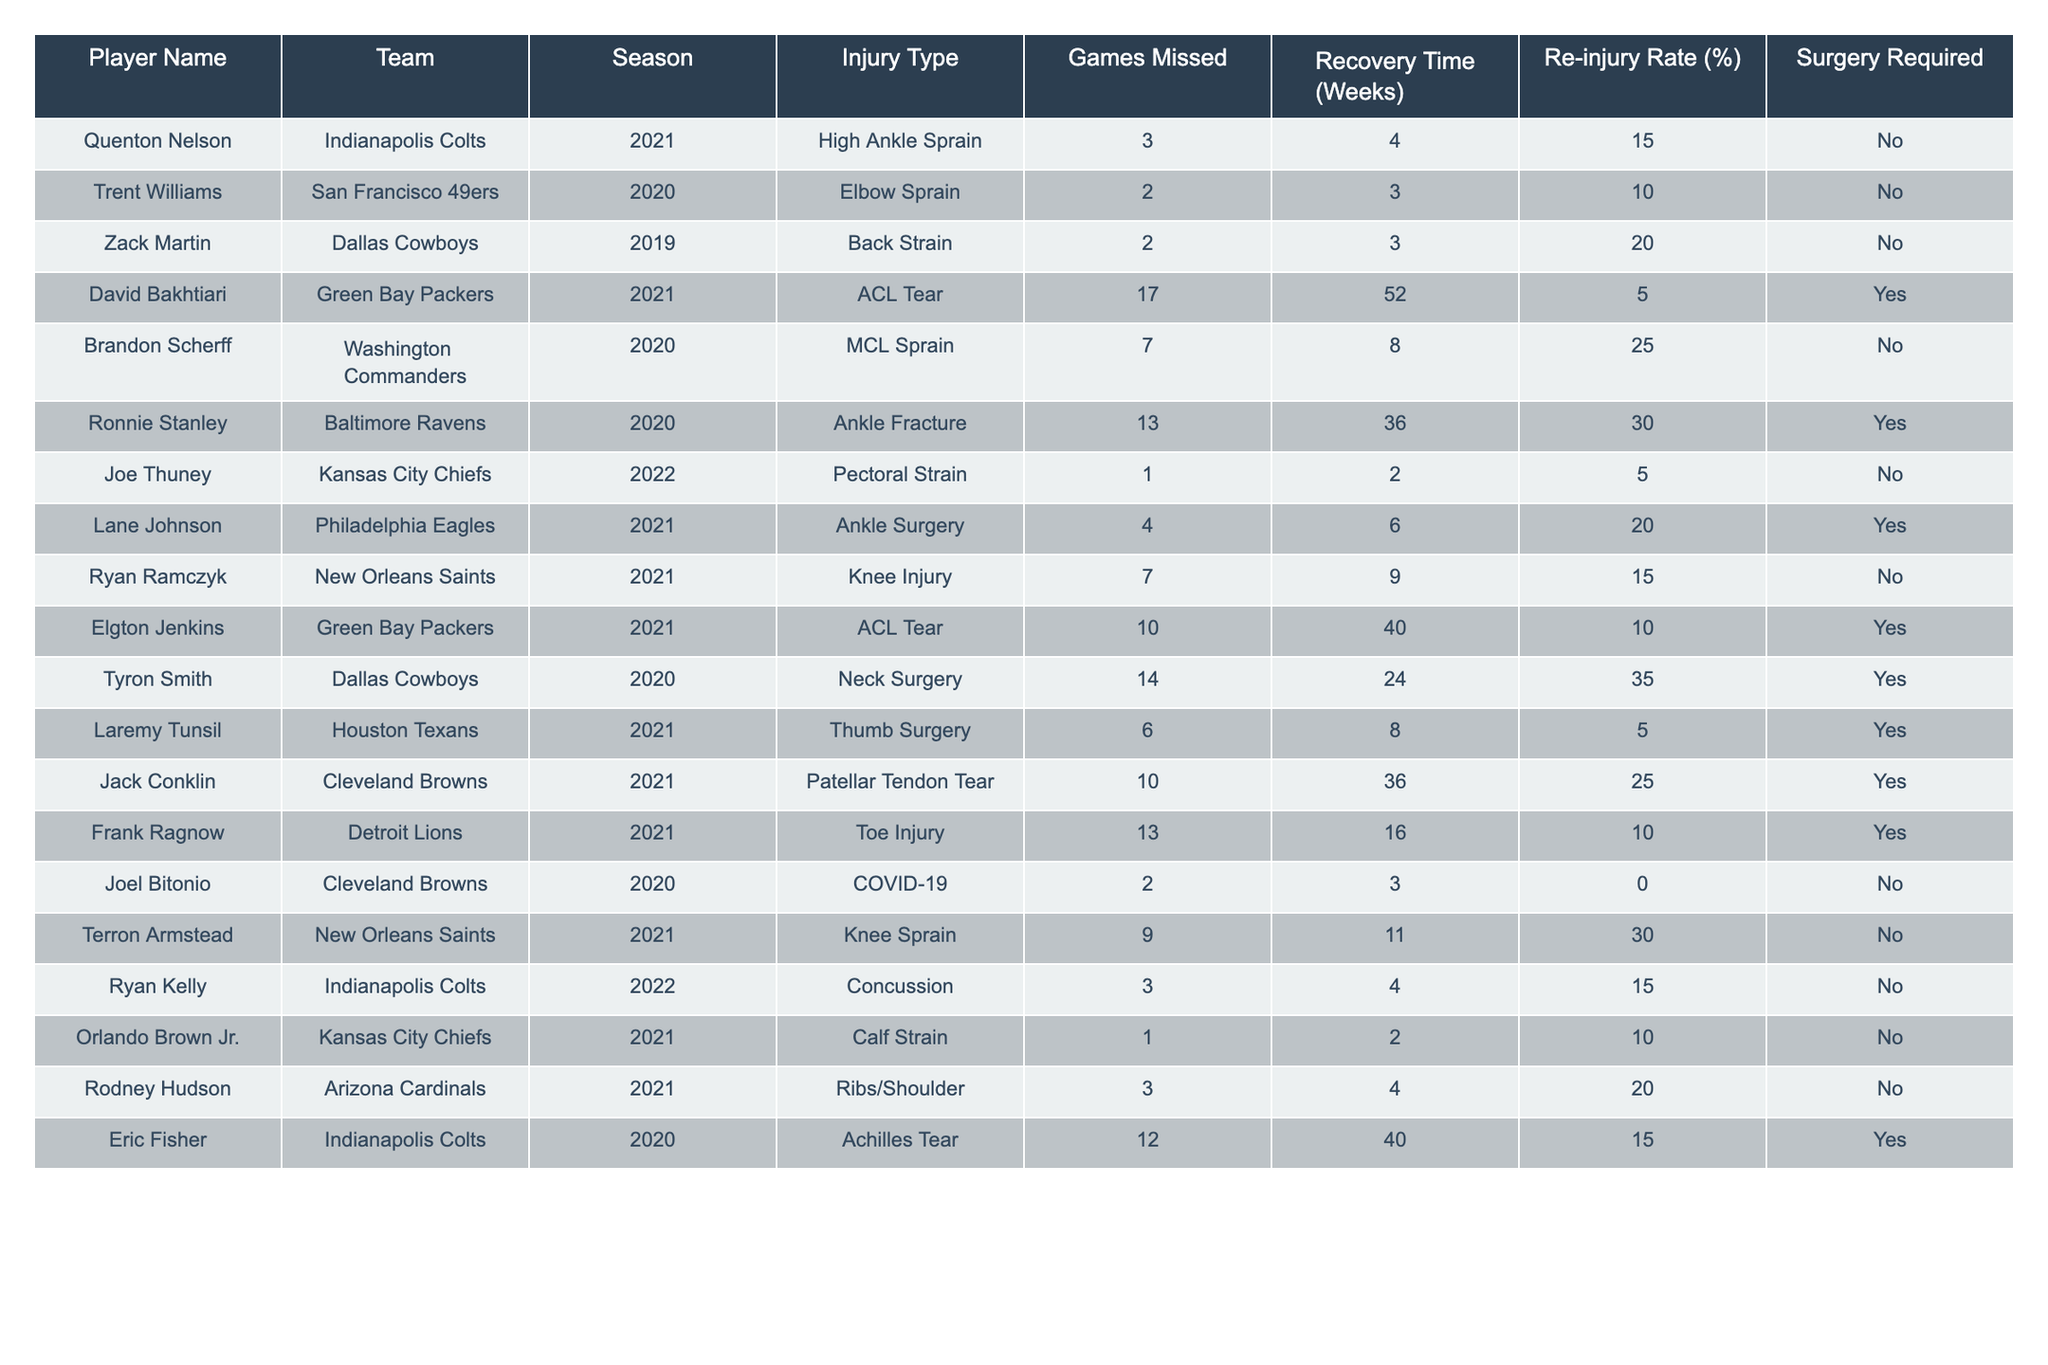What is the total number of games missed by all players due to injuries? To find the total games missed, we need to sum the "Games Missed" column for all players: 3 + 2 + 2 + 17 + 7 + 13 + 1 + 4 + 7 + 10 + 14 + 6 + 10 + 13 + 2 + 9 + 3 + 1 + 3 + 12 = 133.
Answer: 133 Which team had the highest number of injured players during the 2021 season? By reviewing the table for the 2021 season, we find that the Indianapolis Colts and the Green Bay Packers each had 3 injured players. Other teams had fewer players injured in that season.
Answer: Indianapolis Colts and Green Bay Packers What percentage of players required surgery after their injury? To find the percentage of players requiring surgery, we count the number of players needing surgery (6) and divide by the total number of players (20), then multiply by 100: (6/20) * 100 = 30%.
Answer: 30% How many players had a re-injury rate of 20% or higher? We check each player's re-injury rate: 20%, 25%, 30%, 35% indicate 4 players with 20% or higher re-injury rates.
Answer: 4 What's the average recovery time for players with ACL tears? We find the players with ACL tears: David Bakhtiari (52 weeks), Elgton Jenkins (40 weeks) making a total of 92 weeks. The average is 92/2 = 46 weeks.
Answer: 46 weeks Did any player miss more than 10 games in the 2021 season? Checking the 2021 season entries, David Bakhtiari missed 17 games, which is more than 10.
Answer: Yes What is the median recovery time for ankle injuries? Looking at players with ankle injuries, we find: High Ankle Sprain (4 weeks), Ankle Fracture (36 weeks), Ankle Surgery (6 weeks), and Knee Sprain (11 weeks). When arranged, the values are: 4, 6, 11, 36. The median recovery time is (6 + 11)/2 = 8.5 weeks.
Answer: 8.5 weeks Which player had the longest recovery time and what was the injury type? Looking through the recovery time, David Bakhtiari had the longest recovery time of 52 weeks due to an ACL tear.
Answer: David Bakhtiari, ACL Tear How many players missed games due to COVID-19? There was only one player, Joel Bitonio, who missed games due to COVID-19.
Answer: 1 player What is the average number of games missed across all players who had surgery? We find the players who had surgery: 3 + 4 + 14 + 6 + 10 + 13 + 12 = 62. Then divide by the number of players (6): 62/6 = 10.33, the average is roughly 10 games.
Answer: 10.33 